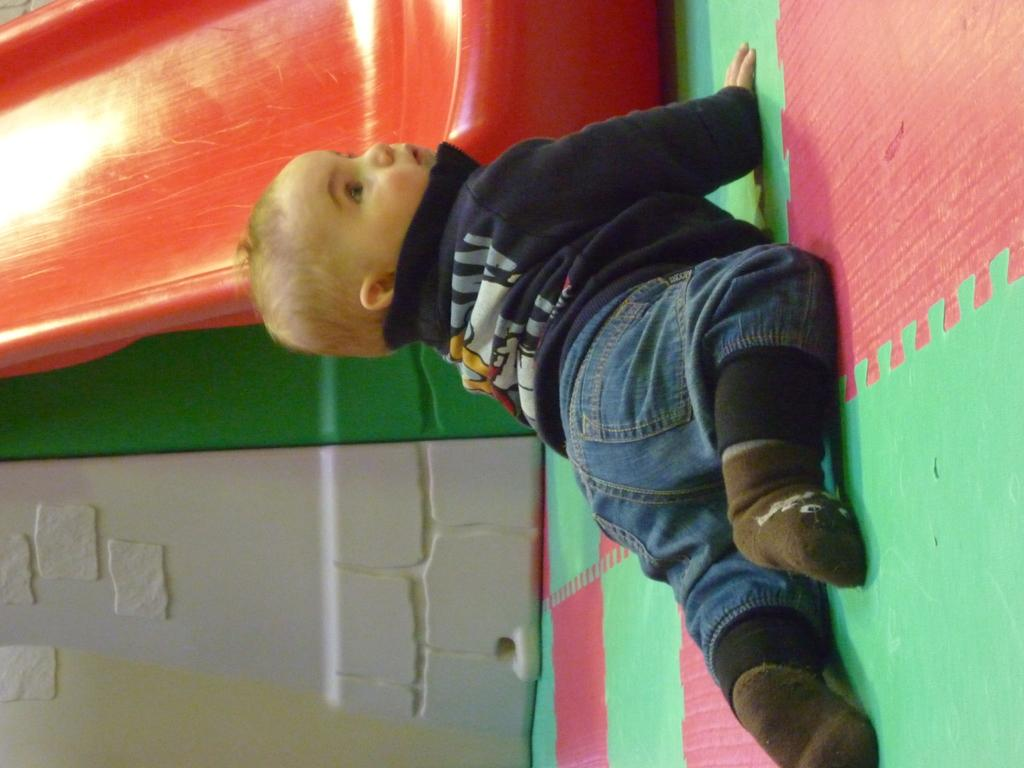What is the main subject of the image? The main subject of the image is a kid. What is the kid doing in the image? The kid is crawling on the floor in the image. What type of playground equipment is present in the image? There is a slide in the image. What can be seen in the background of the image? There is a wall in the image. What type of window control system is visible in the image? There is no window or control system present in the image. What scientific theory is being demonstrated by the kid in the image? There is no scientific theory being demonstrated by the kid in the image. 